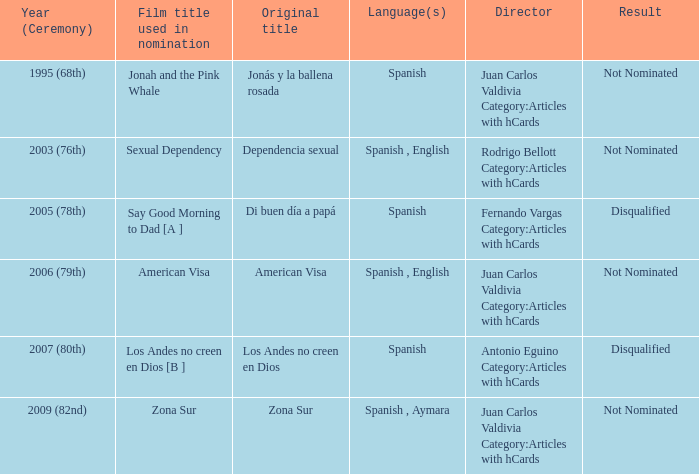What year was Zona Sur nominated? 2009 (82nd). 